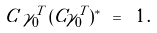Convert formula to latex. <formula><loc_0><loc_0><loc_500><loc_500>C \, \gamma _ { 0 } ^ { T } \, ( C \gamma _ { 0 } ^ { T } ) ^ { * } \ = \ 1 \, .</formula> 